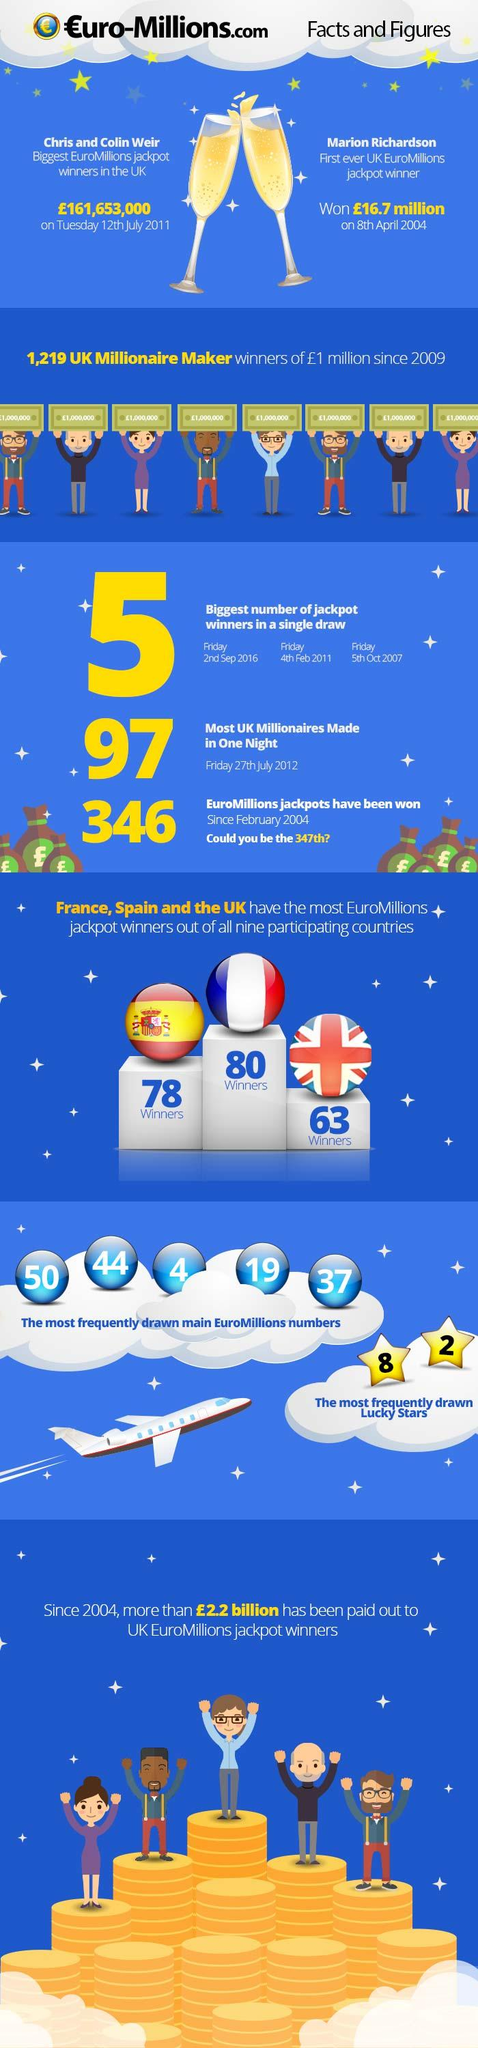Specify some key components in this picture. The number 38 is not one of the most frequently drawn main EuroMillions numbers, which are 50, 44, 4, 38, and 37. France is the country with the highest number of Euromillions jackpot winners. It is incorrect to believe that star number 4, 8, or 2 is a lucky star. The UK has the lowest Euromillions jackpot winner among the UK, France, and Spain. Spain is the country that comes in second place in terms of the most Euromillions jackpot winners. 